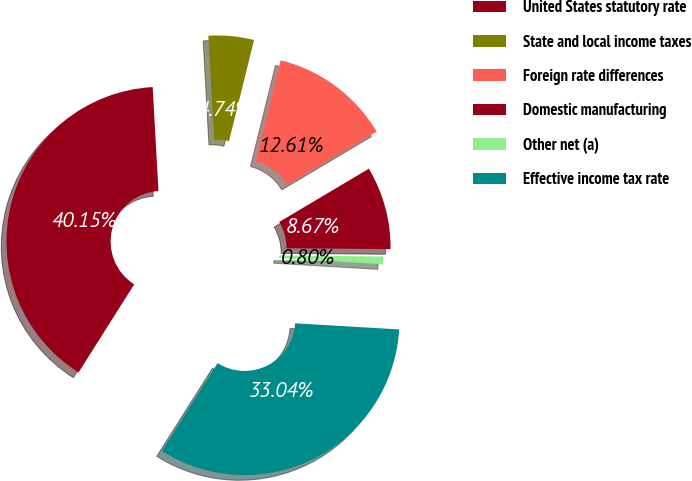<chart> <loc_0><loc_0><loc_500><loc_500><pie_chart><fcel>United States statutory rate<fcel>State and local income taxes<fcel>Foreign rate differences<fcel>Domestic manufacturing<fcel>Other net (a)<fcel>Effective income tax rate<nl><fcel>40.15%<fcel>4.74%<fcel>12.61%<fcel>8.67%<fcel>0.8%<fcel>33.04%<nl></chart> 